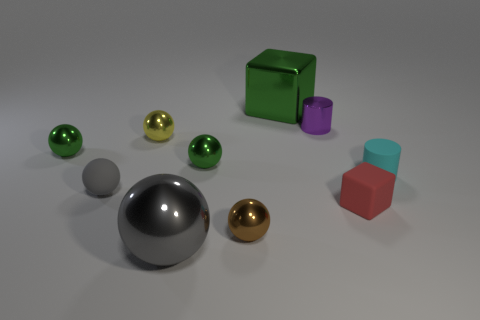There is a small cylinder that is right of the block that is in front of the large green cube; what is it made of?
Your answer should be compact. Rubber. Are there the same number of brown objects that are in front of the big green cube and matte things on the left side of the brown shiny object?
Provide a succinct answer. Yes. Do the tiny brown thing and the big gray object have the same shape?
Make the answer very short. Yes. What is the material of the tiny sphere that is in front of the small matte cylinder and on the left side of the large gray sphere?
Your response must be concise. Rubber. How many small cyan matte objects have the same shape as the small brown thing?
Your answer should be compact. 0. What is the size of the metal cube behind the big object on the left side of the big thing that is behind the tiny yellow shiny ball?
Provide a short and direct response. Large. Is the number of small cylinders to the left of the small red matte block greater than the number of small brown shiny cylinders?
Your answer should be very brief. Yes. Are there any big red metal cylinders?
Offer a very short reply. No. What number of gray things have the same size as the gray metal ball?
Give a very brief answer. 0. Is the number of tiny shiny things that are on the right side of the large sphere greater than the number of big gray metallic things that are to the right of the small matte cylinder?
Provide a short and direct response. Yes. 